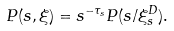<formula> <loc_0><loc_0><loc_500><loc_500>P ( s , \xi ) = s ^ { - \tau _ { s } } P ( s / \xi ^ { D } _ { s } ) .</formula> 